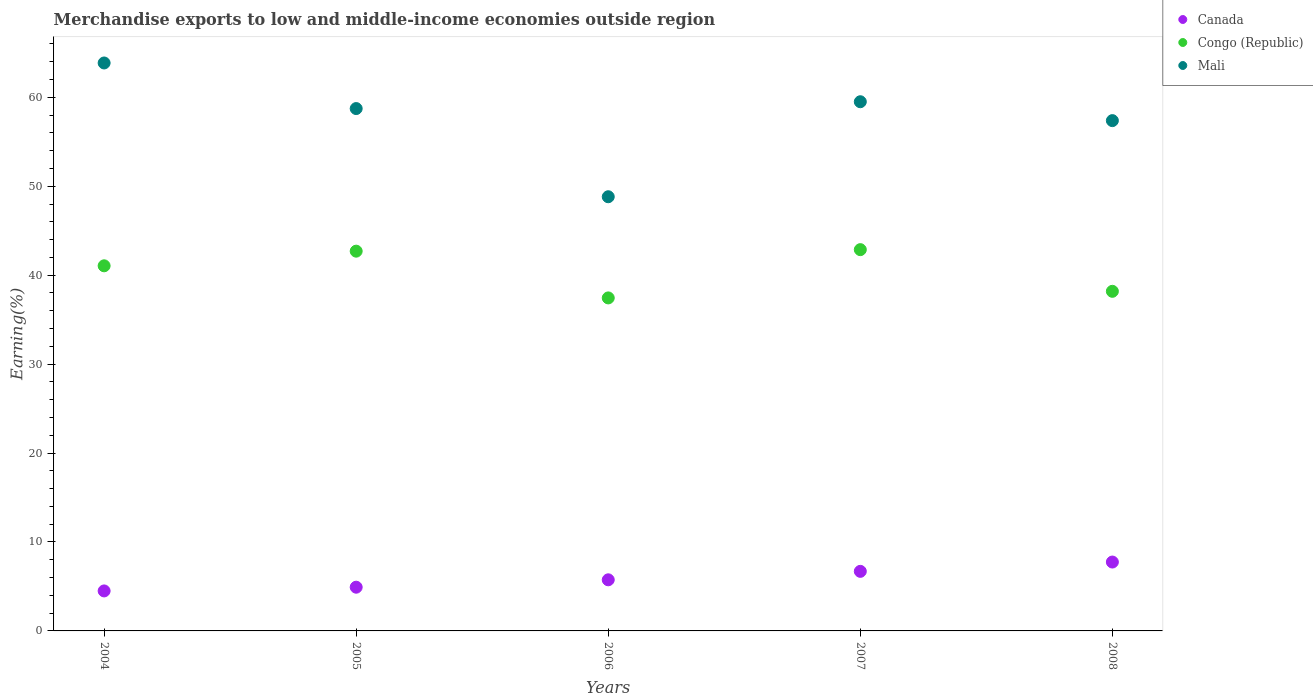What is the percentage of amount earned from merchandise exports in Mali in 2005?
Make the answer very short. 58.74. Across all years, what is the maximum percentage of amount earned from merchandise exports in Congo (Republic)?
Ensure brevity in your answer.  42.87. Across all years, what is the minimum percentage of amount earned from merchandise exports in Mali?
Ensure brevity in your answer.  48.82. In which year was the percentage of amount earned from merchandise exports in Congo (Republic) minimum?
Provide a succinct answer. 2006. What is the total percentage of amount earned from merchandise exports in Mali in the graph?
Make the answer very short. 288.3. What is the difference between the percentage of amount earned from merchandise exports in Canada in 2007 and that in 2008?
Provide a short and direct response. -1.05. What is the difference between the percentage of amount earned from merchandise exports in Canada in 2007 and the percentage of amount earned from merchandise exports in Congo (Republic) in 2008?
Ensure brevity in your answer.  -31.49. What is the average percentage of amount earned from merchandise exports in Congo (Republic) per year?
Provide a short and direct response. 40.45. In the year 2008, what is the difference between the percentage of amount earned from merchandise exports in Congo (Republic) and percentage of amount earned from merchandise exports in Mali?
Make the answer very short. -19.19. What is the ratio of the percentage of amount earned from merchandise exports in Congo (Republic) in 2005 to that in 2006?
Provide a succinct answer. 1.14. Is the percentage of amount earned from merchandise exports in Canada in 2004 less than that in 2006?
Offer a terse response. Yes. Is the difference between the percentage of amount earned from merchandise exports in Congo (Republic) in 2004 and 2006 greater than the difference between the percentage of amount earned from merchandise exports in Mali in 2004 and 2006?
Your answer should be compact. No. What is the difference between the highest and the second highest percentage of amount earned from merchandise exports in Mali?
Make the answer very short. 4.36. What is the difference between the highest and the lowest percentage of amount earned from merchandise exports in Mali?
Provide a short and direct response. 15.04. In how many years, is the percentage of amount earned from merchandise exports in Canada greater than the average percentage of amount earned from merchandise exports in Canada taken over all years?
Provide a succinct answer. 2. Is the sum of the percentage of amount earned from merchandise exports in Canada in 2007 and 2008 greater than the maximum percentage of amount earned from merchandise exports in Mali across all years?
Provide a short and direct response. No. Is it the case that in every year, the sum of the percentage of amount earned from merchandise exports in Canada and percentage of amount earned from merchandise exports in Congo (Republic)  is greater than the percentage of amount earned from merchandise exports in Mali?
Your response must be concise. No. Does the percentage of amount earned from merchandise exports in Congo (Republic) monotonically increase over the years?
Your answer should be compact. No. How many dotlines are there?
Give a very brief answer. 3. What is the difference between two consecutive major ticks on the Y-axis?
Your answer should be compact. 10. Are the values on the major ticks of Y-axis written in scientific E-notation?
Keep it short and to the point. No. Where does the legend appear in the graph?
Provide a short and direct response. Top right. How many legend labels are there?
Your response must be concise. 3. How are the legend labels stacked?
Ensure brevity in your answer.  Vertical. What is the title of the graph?
Provide a short and direct response. Merchandise exports to low and middle-income economies outside region. Does "Slovak Republic" appear as one of the legend labels in the graph?
Your response must be concise. No. What is the label or title of the Y-axis?
Your answer should be very brief. Earning(%). What is the Earning(%) of Canada in 2004?
Your answer should be compact. 4.5. What is the Earning(%) of Congo (Republic) in 2004?
Provide a short and direct response. 41.05. What is the Earning(%) of Mali in 2004?
Provide a succinct answer. 63.86. What is the Earning(%) in Canada in 2005?
Give a very brief answer. 4.92. What is the Earning(%) in Congo (Republic) in 2005?
Provide a succinct answer. 42.7. What is the Earning(%) in Mali in 2005?
Make the answer very short. 58.74. What is the Earning(%) in Canada in 2006?
Provide a succinct answer. 5.75. What is the Earning(%) of Congo (Republic) in 2006?
Make the answer very short. 37.44. What is the Earning(%) of Mali in 2006?
Ensure brevity in your answer.  48.82. What is the Earning(%) in Canada in 2007?
Your response must be concise. 6.7. What is the Earning(%) of Congo (Republic) in 2007?
Give a very brief answer. 42.87. What is the Earning(%) in Mali in 2007?
Your answer should be compact. 59.5. What is the Earning(%) of Canada in 2008?
Provide a short and direct response. 7.74. What is the Earning(%) in Congo (Republic) in 2008?
Your answer should be compact. 38.19. What is the Earning(%) of Mali in 2008?
Offer a terse response. 57.38. Across all years, what is the maximum Earning(%) of Canada?
Your response must be concise. 7.74. Across all years, what is the maximum Earning(%) of Congo (Republic)?
Make the answer very short. 42.87. Across all years, what is the maximum Earning(%) in Mali?
Provide a short and direct response. 63.86. Across all years, what is the minimum Earning(%) of Canada?
Provide a short and direct response. 4.5. Across all years, what is the minimum Earning(%) in Congo (Republic)?
Keep it short and to the point. 37.44. Across all years, what is the minimum Earning(%) of Mali?
Make the answer very short. 48.82. What is the total Earning(%) of Canada in the graph?
Keep it short and to the point. 29.6. What is the total Earning(%) of Congo (Republic) in the graph?
Give a very brief answer. 202.26. What is the total Earning(%) in Mali in the graph?
Your answer should be very brief. 288.3. What is the difference between the Earning(%) in Canada in 2004 and that in 2005?
Ensure brevity in your answer.  -0.42. What is the difference between the Earning(%) of Congo (Republic) in 2004 and that in 2005?
Offer a very short reply. -1.65. What is the difference between the Earning(%) of Mali in 2004 and that in 2005?
Keep it short and to the point. 5.13. What is the difference between the Earning(%) of Canada in 2004 and that in 2006?
Provide a succinct answer. -1.25. What is the difference between the Earning(%) of Congo (Republic) in 2004 and that in 2006?
Offer a terse response. 3.61. What is the difference between the Earning(%) of Mali in 2004 and that in 2006?
Your response must be concise. 15.04. What is the difference between the Earning(%) of Canada in 2004 and that in 2007?
Keep it short and to the point. -2.2. What is the difference between the Earning(%) in Congo (Republic) in 2004 and that in 2007?
Keep it short and to the point. -1.82. What is the difference between the Earning(%) of Mali in 2004 and that in 2007?
Your response must be concise. 4.36. What is the difference between the Earning(%) in Canada in 2004 and that in 2008?
Your answer should be compact. -3.25. What is the difference between the Earning(%) of Congo (Republic) in 2004 and that in 2008?
Your response must be concise. 2.87. What is the difference between the Earning(%) of Mali in 2004 and that in 2008?
Your response must be concise. 6.48. What is the difference between the Earning(%) in Canada in 2005 and that in 2006?
Provide a short and direct response. -0.83. What is the difference between the Earning(%) in Congo (Republic) in 2005 and that in 2006?
Give a very brief answer. 5.26. What is the difference between the Earning(%) in Mali in 2005 and that in 2006?
Provide a short and direct response. 9.92. What is the difference between the Earning(%) in Canada in 2005 and that in 2007?
Give a very brief answer. -1.78. What is the difference between the Earning(%) in Congo (Republic) in 2005 and that in 2007?
Your response must be concise. -0.17. What is the difference between the Earning(%) in Mali in 2005 and that in 2007?
Provide a short and direct response. -0.77. What is the difference between the Earning(%) in Canada in 2005 and that in 2008?
Your response must be concise. -2.83. What is the difference between the Earning(%) in Congo (Republic) in 2005 and that in 2008?
Provide a succinct answer. 4.51. What is the difference between the Earning(%) of Mali in 2005 and that in 2008?
Give a very brief answer. 1.36. What is the difference between the Earning(%) in Canada in 2006 and that in 2007?
Your answer should be very brief. -0.95. What is the difference between the Earning(%) in Congo (Republic) in 2006 and that in 2007?
Offer a terse response. -5.43. What is the difference between the Earning(%) in Mali in 2006 and that in 2007?
Make the answer very short. -10.68. What is the difference between the Earning(%) of Canada in 2006 and that in 2008?
Keep it short and to the point. -2. What is the difference between the Earning(%) of Congo (Republic) in 2006 and that in 2008?
Give a very brief answer. -0.74. What is the difference between the Earning(%) in Mali in 2006 and that in 2008?
Give a very brief answer. -8.56. What is the difference between the Earning(%) in Canada in 2007 and that in 2008?
Offer a terse response. -1.05. What is the difference between the Earning(%) of Congo (Republic) in 2007 and that in 2008?
Ensure brevity in your answer.  4.69. What is the difference between the Earning(%) of Mali in 2007 and that in 2008?
Ensure brevity in your answer.  2.12. What is the difference between the Earning(%) of Canada in 2004 and the Earning(%) of Congo (Republic) in 2005?
Make the answer very short. -38.2. What is the difference between the Earning(%) of Canada in 2004 and the Earning(%) of Mali in 2005?
Make the answer very short. -54.24. What is the difference between the Earning(%) in Congo (Republic) in 2004 and the Earning(%) in Mali in 2005?
Keep it short and to the point. -17.68. What is the difference between the Earning(%) of Canada in 2004 and the Earning(%) of Congo (Republic) in 2006?
Keep it short and to the point. -32.95. What is the difference between the Earning(%) in Canada in 2004 and the Earning(%) in Mali in 2006?
Your response must be concise. -44.32. What is the difference between the Earning(%) in Congo (Republic) in 2004 and the Earning(%) in Mali in 2006?
Offer a very short reply. -7.77. What is the difference between the Earning(%) of Canada in 2004 and the Earning(%) of Congo (Republic) in 2007?
Keep it short and to the point. -38.37. What is the difference between the Earning(%) in Canada in 2004 and the Earning(%) in Mali in 2007?
Your answer should be very brief. -55.01. What is the difference between the Earning(%) of Congo (Republic) in 2004 and the Earning(%) of Mali in 2007?
Your answer should be compact. -18.45. What is the difference between the Earning(%) of Canada in 2004 and the Earning(%) of Congo (Republic) in 2008?
Provide a short and direct response. -33.69. What is the difference between the Earning(%) in Canada in 2004 and the Earning(%) in Mali in 2008?
Make the answer very short. -52.88. What is the difference between the Earning(%) in Congo (Republic) in 2004 and the Earning(%) in Mali in 2008?
Make the answer very short. -16.32. What is the difference between the Earning(%) of Canada in 2005 and the Earning(%) of Congo (Republic) in 2006?
Your answer should be very brief. -32.53. What is the difference between the Earning(%) of Canada in 2005 and the Earning(%) of Mali in 2006?
Ensure brevity in your answer.  -43.9. What is the difference between the Earning(%) in Congo (Republic) in 2005 and the Earning(%) in Mali in 2006?
Give a very brief answer. -6.12. What is the difference between the Earning(%) of Canada in 2005 and the Earning(%) of Congo (Republic) in 2007?
Give a very brief answer. -37.96. What is the difference between the Earning(%) of Canada in 2005 and the Earning(%) of Mali in 2007?
Make the answer very short. -54.59. What is the difference between the Earning(%) of Congo (Republic) in 2005 and the Earning(%) of Mali in 2007?
Provide a succinct answer. -16.8. What is the difference between the Earning(%) of Canada in 2005 and the Earning(%) of Congo (Republic) in 2008?
Offer a terse response. -33.27. What is the difference between the Earning(%) of Canada in 2005 and the Earning(%) of Mali in 2008?
Ensure brevity in your answer.  -52.46. What is the difference between the Earning(%) of Congo (Republic) in 2005 and the Earning(%) of Mali in 2008?
Give a very brief answer. -14.68. What is the difference between the Earning(%) in Canada in 2006 and the Earning(%) in Congo (Republic) in 2007?
Offer a terse response. -37.12. What is the difference between the Earning(%) of Canada in 2006 and the Earning(%) of Mali in 2007?
Ensure brevity in your answer.  -53.76. What is the difference between the Earning(%) in Congo (Republic) in 2006 and the Earning(%) in Mali in 2007?
Your response must be concise. -22.06. What is the difference between the Earning(%) in Canada in 2006 and the Earning(%) in Congo (Republic) in 2008?
Keep it short and to the point. -32.44. What is the difference between the Earning(%) in Canada in 2006 and the Earning(%) in Mali in 2008?
Your answer should be very brief. -51.63. What is the difference between the Earning(%) of Congo (Republic) in 2006 and the Earning(%) of Mali in 2008?
Give a very brief answer. -19.94. What is the difference between the Earning(%) in Canada in 2007 and the Earning(%) in Congo (Republic) in 2008?
Your answer should be very brief. -31.49. What is the difference between the Earning(%) of Canada in 2007 and the Earning(%) of Mali in 2008?
Offer a terse response. -50.68. What is the difference between the Earning(%) in Congo (Republic) in 2007 and the Earning(%) in Mali in 2008?
Your answer should be very brief. -14.51. What is the average Earning(%) in Canada per year?
Make the answer very short. 5.92. What is the average Earning(%) in Congo (Republic) per year?
Make the answer very short. 40.45. What is the average Earning(%) in Mali per year?
Provide a succinct answer. 57.66. In the year 2004, what is the difference between the Earning(%) of Canada and Earning(%) of Congo (Republic)?
Give a very brief answer. -36.56. In the year 2004, what is the difference between the Earning(%) in Canada and Earning(%) in Mali?
Your answer should be very brief. -59.37. In the year 2004, what is the difference between the Earning(%) of Congo (Republic) and Earning(%) of Mali?
Provide a succinct answer. -22.81. In the year 2005, what is the difference between the Earning(%) in Canada and Earning(%) in Congo (Republic)?
Offer a very short reply. -37.79. In the year 2005, what is the difference between the Earning(%) in Canada and Earning(%) in Mali?
Your response must be concise. -53.82. In the year 2005, what is the difference between the Earning(%) of Congo (Republic) and Earning(%) of Mali?
Give a very brief answer. -16.03. In the year 2006, what is the difference between the Earning(%) in Canada and Earning(%) in Congo (Republic)?
Make the answer very short. -31.7. In the year 2006, what is the difference between the Earning(%) of Canada and Earning(%) of Mali?
Your answer should be very brief. -43.07. In the year 2006, what is the difference between the Earning(%) in Congo (Republic) and Earning(%) in Mali?
Offer a very short reply. -11.38. In the year 2007, what is the difference between the Earning(%) of Canada and Earning(%) of Congo (Republic)?
Your response must be concise. -36.17. In the year 2007, what is the difference between the Earning(%) in Canada and Earning(%) in Mali?
Keep it short and to the point. -52.8. In the year 2007, what is the difference between the Earning(%) of Congo (Republic) and Earning(%) of Mali?
Keep it short and to the point. -16.63. In the year 2008, what is the difference between the Earning(%) in Canada and Earning(%) in Congo (Republic)?
Your answer should be compact. -30.44. In the year 2008, what is the difference between the Earning(%) in Canada and Earning(%) in Mali?
Offer a very short reply. -49.63. In the year 2008, what is the difference between the Earning(%) of Congo (Republic) and Earning(%) of Mali?
Offer a terse response. -19.19. What is the ratio of the Earning(%) in Canada in 2004 to that in 2005?
Your response must be concise. 0.91. What is the ratio of the Earning(%) in Congo (Republic) in 2004 to that in 2005?
Offer a terse response. 0.96. What is the ratio of the Earning(%) of Mali in 2004 to that in 2005?
Keep it short and to the point. 1.09. What is the ratio of the Earning(%) in Canada in 2004 to that in 2006?
Offer a terse response. 0.78. What is the ratio of the Earning(%) of Congo (Republic) in 2004 to that in 2006?
Your answer should be compact. 1.1. What is the ratio of the Earning(%) of Mali in 2004 to that in 2006?
Ensure brevity in your answer.  1.31. What is the ratio of the Earning(%) of Canada in 2004 to that in 2007?
Your response must be concise. 0.67. What is the ratio of the Earning(%) in Congo (Republic) in 2004 to that in 2007?
Ensure brevity in your answer.  0.96. What is the ratio of the Earning(%) in Mali in 2004 to that in 2007?
Provide a succinct answer. 1.07. What is the ratio of the Earning(%) of Canada in 2004 to that in 2008?
Make the answer very short. 0.58. What is the ratio of the Earning(%) of Congo (Republic) in 2004 to that in 2008?
Your answer should be very brief. 1.08. What is the ratio of the Earning(%) of Mali in 2004 to that in 2008?
Provide a short and direct response. 1.11. What is the ratio of the Earning(%) of Canada in 2005 to that in 2006?
Offer a very short reply. 0.86. What is the ratio of the Earning(%) in Congo (Republic) in 2005 to that in 2006?
Make the answer very short. 1.14. What is the ratio of the Earning(%) of Mali in 2005 to that in 2006?
Provide a succinct answer. 1.2. What is the ratio of the Earning(%) of Canada in 2005 to that in 2007?
Provide a short and direct response. 0.73. What is the ratio of the Earning(%) of Mali in 2005 to that in 2007?
Make the answer very short. 0.99. What is the ratio of the Earning(%) of Canada in 2005 to that in 2008?
Your answer should be compact. 0.63. What is the ratio of the Earning(%) of Congo (Republic) in 2005 to that in 2008?
Your answer should be very brief. 1.12. What is the ratio of the Earning(%) of Mali in 2005 to that in 2008?
Make the answer very short. 1.02. What is the ratio of the Earning(%) in Canada in 2006 to that in 2007?
Your answer should be compact. 0.86. What is the ratio of the Earning(%) of Congo (Republic) in 2006 to that in 2007?
Provide a succinct answer. 0.87. What is the ratio of the Earning(%) of Mali in 2006 to that in 2007?
Provide a short and direct response. 0.82. What is the ratio of the Earning(%) of Canada in 2006 to that in 2008?
Your answer should be compact. 0.74. What is the ratio of the Earning(%) of Congo (Republic) in 2006 to that in 2008?
Ensure brevity in your answer.  0.98. What is the ratio of the Earning(%) of Mali in 2006 to that in 2008?
Make the answer very short. 0.85. What is the ratio of the Earning(%) of Canada in 2007 to that in 2008?
Ensure brevity in your answer.  0.86. What is the ratio of the Earning(%) in Congo (Republic) in 2007 to that in 2008?
Your answer should be very brief. 1.12. What is the ratio of the Earning(%) in Mali in 2007 to that in 2008?
Ensure brevity in your answer.  1.04. What is the difference between the highest and the second highest Earning(%) of Canada?
Your answer should be compact. 1.05. What is the difference between the highest and the second highest Earning(%) of Congo (Republic)?
Make the answer very short. 0.17. What is the difference between the highest and the second highest Earning(%) in Mali?
Keep it short and to the point. 4.36. What is the difference between the highest and the lowest Earning(%) of Canada?
Your answer should be very brief. 3.25. What is the difference between the highest and the lowest Earning(%) in Congo (Republic)?
Make the answer very short. 5.43. What is the difference between the highest and the lowest Earning(%) of Mali?
Keep it short and to the point. 15.04. 